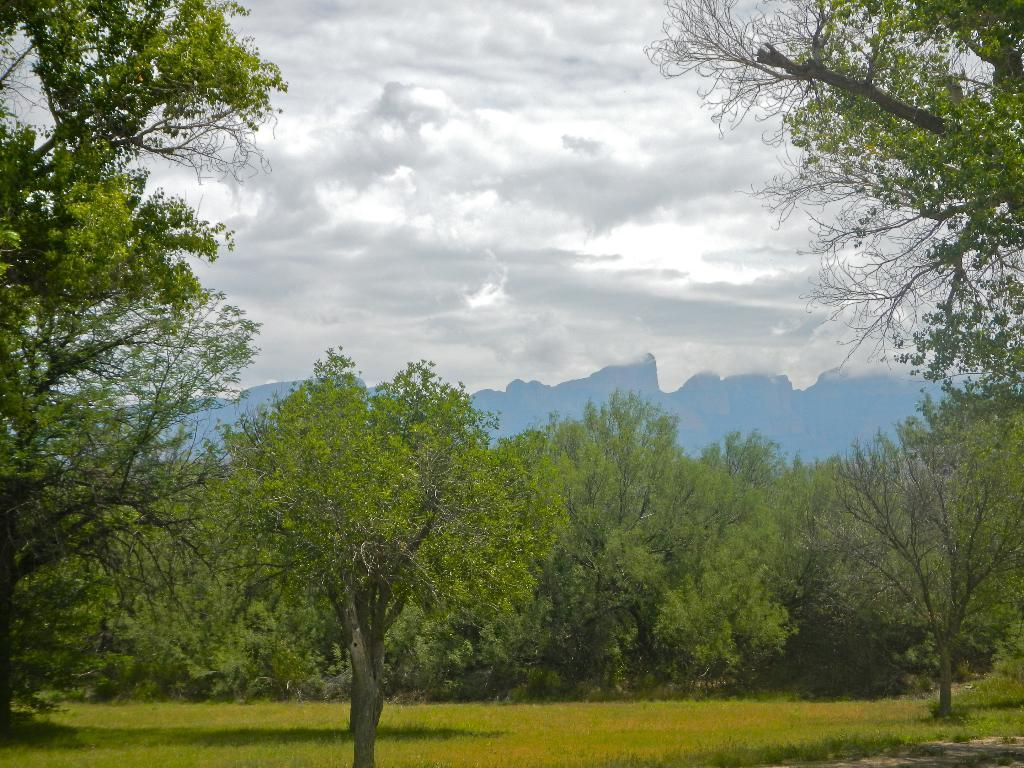What type of vegetation can be seen on the grassy land in the image? There are trees on the grassy land in the image. What is visible at the top of the image? The sky is visible at the top of the image. What can be observed in the sky? Clouds are present in the sky. Where is the lift located in the image? There is no lift present in the image. What type of beef can be seen in the image? There is no beef present in the image. 